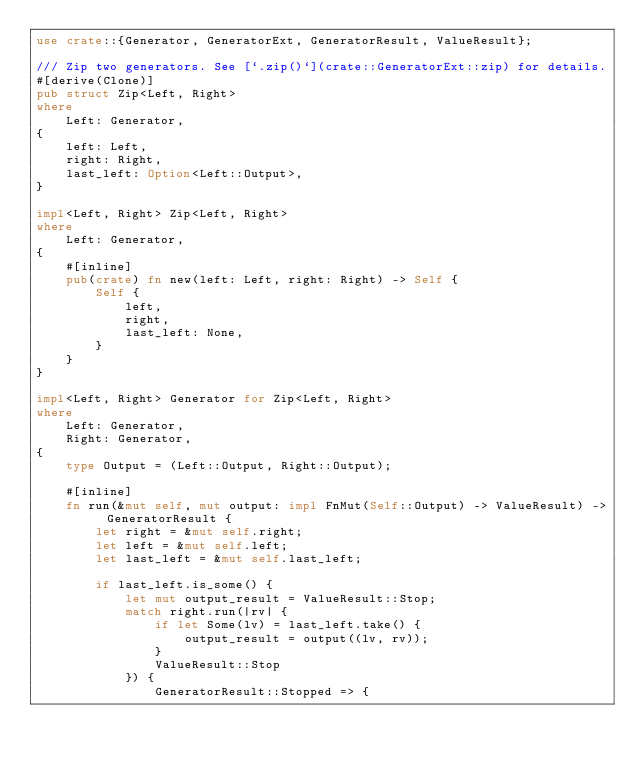Convert code to text. <code><loc_0><loc_0><loc_500><loc_500><_Rust_>use crate::{Generator, GeneratorExt, GeneratorResult, ValueResult};

/// Zip two generators. See [`.zip()`](crate::GeneratorExt::zip) for details.
#[derive(Clone)]
pub struct Zip<Left, Right>
where
    Left: Generator,
{
    left: Left,
    right: Right,
    last_left: Option<Left::Output>,
}

impl<Left, Right> Zip<Left, Right>
where
    Left: Generator,
{
    #[inline]
    pub(crate) fn new(left: Left, right: Right) -> Self {
        Self {
            left,
            right,
            last_left: None,
        }
    }
}

impl<Left, Right> Generator for Zip<Left, Right>
where
    Left: Generator,
    Right: Generator,
{
    type Output = (Left::Output, Right::Output);

    #[inline]
    fn run(&mut self, mut output: impl FnMut(Self::Output) -> ValueResult) -> GeneratorResult {
        let right = &mut self.right;
        let left = &mut self.left;
        let last_left = &mut self.last_left;

        if last_left.is_some() {
            let mut output_result = ValueResult::Stop;
            match right.run(|rv| {
                if let Some(lv) = last_left.take() {
                    output_result = output((lv, rv));
                }
                ValueResult::Stop
            }) {
                GeneratorResult::Stopped => {</code> 